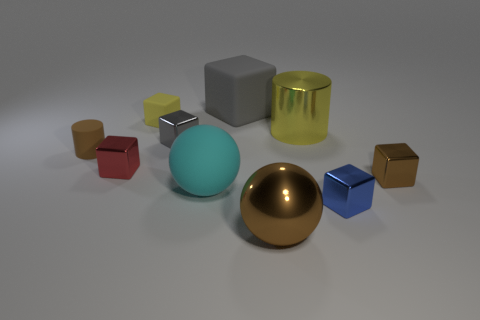Subtract 1 blocks. How many blocks are left? 5 Subtract all small gray cubes. How many cubes are left? 5 Subtract all brown cubes. How many cubes are left? 5 Subtract all blue blocks. Subtract all gray balls. How many blocks are left? 5 Subtract all cylinders. How many objects are left? 8 Subtract 1 red cubes. How many objects are left? 9 Subtract all big green metallic spheres. Subtract all rubber balls. How many objects are left? 9 Add 3 big cyan rubber balls. How many big cyan rubber balls are left? 4 Add 6 gray shiny things. How many gray shiny things exist? 7 